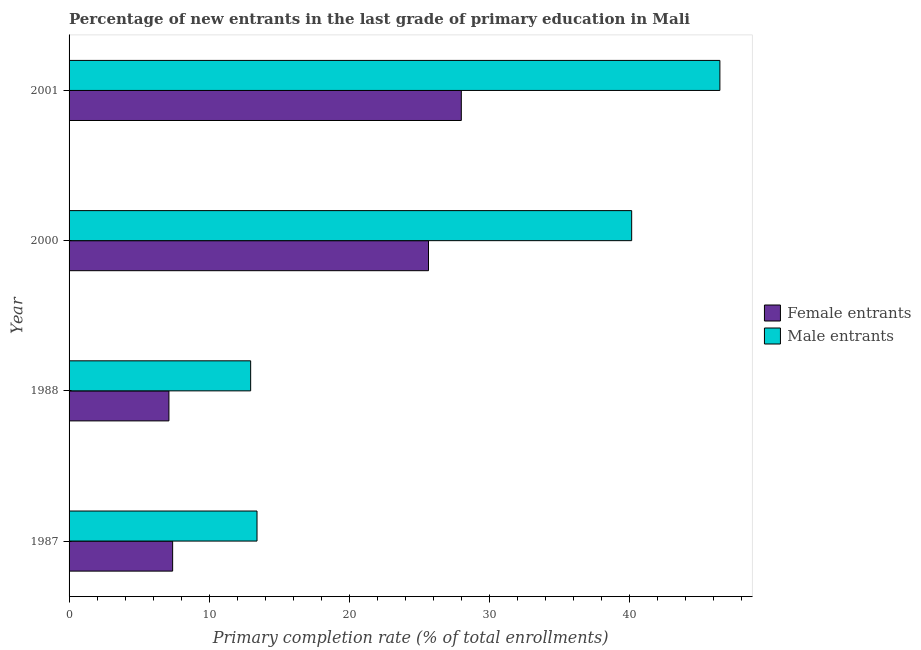How many different coloured bars are there?
Offer a very short reply. 2. How many groups of bars are there?
Your response must be concise. 4. How many bars are there on the 1st tick from the top?
Keep it short and to the point. 2. How many bars are there on the 1st tick from the bottom?
Your answer should be very brief. 2. In how many cases, is the number of bars for a given year not equal to the number of legend labels?
Give a very brief answer. 0. What is the primary completion rate of male entrants in 2000?
Ensure brevity in your answer.  40.15. Across all years, what is the maximum primary completion rate of male entrants?
Offer a terse response. 46.45. Across all years, what is the minimum primary completion rate of male entrants?
Offer a very short reply. 12.96. In which year was the primary completion rate of male entrants minimum?
Provide a short and direct response. 1988. What is the total primary completion rate of male entrants in the graph?
Ensure brevity in your answer.  112.97. What is the difference between the primary completion rate of female entrants in 2000 and that in 2001?
Provide a short and direct response. -2.34. What is the difference between the primary completion rate of female entrants in 2000 and the primary completion rate of male entrants in 1988?
Provide a succinct answer. 12.69. What is the average primary completion rate of female entrants per year?
Your answer should be compact. 17.04. In the year 2001, what is the difference between the primary completion rate of female entrants and primary completion rate of male entrants?
Provide a succinct answer. -18.45. In how many years, is the primary completion rate of male entrants greater than 46 %?
Provide a short and direct response. 1. What is the ratio of the primary completion rate of male entrants in 1987 to that in 2000?
Your answer should be very brief. 0.33. Is the primary completion rate of male entrants in 1987 less than that in 1988?
Your answer should be very brief. No. What is the difference between the highest and the second highest primary completion rate of male entrants?
Provide a succinct answer. 6.3. What is the difference between the highest and the lowest primary completion rate of female entrants?
Ensure brevity in your answer.  20.87. In how many years, is the primary completion rate of female entrants greater than the average primary completion rate of female entrants taken over all years?
Provide a succinct answer. 2. What does the 1st bar from the top in 2000 represents?
Provide a succinct answer. Male entrants. What does the 2nd bar from the bottom in 2001 represents?
Give a very brief answer. Male entrants. Are all the bars in the graph horizontal?
Make the answer very short. Yes. How many years are there in the graph?
Offer a terse response. 4. Are the values on the major ticks of X-axis written in scientific E-notation?
Offer a very short reply. No. Where does the legend appear in the graph?
Offer a terse response. Center right. How are the legend labels stacked?
Your answer should be compact. Vertical. What is the title of the graph?
Make the answer very short. Percentage of new entrants in the last grade of primary education in Mali. Does "Resident workers" appear as one of the legend labels in the graph?
Provide a succinct answer. No. What is the label or title of the X-axis?
Ensure brevity in your answer.  Primary completion rate (% of total enrollments). What is the label or title of the Y-axis?
Provide a succinct answer. Year. What is the Primary completion rate (% of total enrollments) in Female entrants in 1987?
Give a very brief answer. 7.39. What is the Primary completion rate (% of total enrollments) of Male entrants in 1987?
Provide a succinct answer. 13.41. What is the Primary completion rate (% of total enrollments) of Female entrants in 1988?
Provide a short and direct response. 7.13. What is the Primary completion rate (% of total enrollments) in Male entrants in 1988?
Offer a very short reply. 12.96. What is the Primary completion rate (% of total enrollments) in Female entrants in 2000?
Your response must be concise. 25.65. What is the Primary completion rate (% of total enrollments) of Male entrants in 2000?
Your answer should be very brief. 40.15. What is the Primary completion rate (% of total enrollments) of Female entrants in 2001?
Offer a very short reply. 27.99. What is the Primary completion rate (% of total enrollments) of Male entrants in 2001?
Your response must be concise. 46.45. Across all years, what is the maximum Primary completion rate (% of total enrollments) of Female entrants?
Your answer should be very brief. 27.99. Across all years, what is the maximum Primary completion rate (% of total enrollments) in Male entrants?
Keep it short and to the point. 46.45. Across all years, what is the minimum Primary completion rate (% of total enrollments) in Female entrants?
Keep it short and to the point. 7.13. Across all years, what is the minimum Primary completion rate (% of total enrollments) in Male entrants?
Offer a terse response. 12.96. What is the total Primary completion rate (% of total enrollments) in Female entrants in the graph?
Give a very brief answer. 68.16. What is the total Primary completion rate (% of total enrollments) of Male entrants in the graph?
Your response must be concise. 112.97. What is the difference between the Primary completion rate (% of total enrollments) of Female entrants in 1987 and that in 1988?
Keep it short and to the point. 0.27. What is the difference between the Primary completion rate (% of total enrollments) in Male entrants in 1987 and that in 1988?
Your answer should be very brief. 0.45. What is the difference between the Primary completion rate (% of total enrollments) in Female entrants in 1987 and that in 2000?
Your response must be concise. -18.26. What is the difference between the Primary completion rate (% of total enrollments) in Male entrants in 1987 and that in 2000?
Provide a short and direct response. -26.74. What is the difference between the Primary completion rate (% of total enrollments) of Female entrants in 1987 and that in 2001?
Give a very brief answer. -20.6. What is the difference between the Primary completion rate (% of total enrollments) of Male entrants in 1987 and that in 2001?
Provide a succinct answer. -33.03. What is the difference between the Primary completion rate (% of total enrollments) in Female entrants in 1988 and that in 2000?
Your answer should be compact. -18.52. What is the difference between the Primary completion rate (% of total enrollments) in Male entrants in 1988 and that in 2000?
Your answer should be compact. -27.19. What is the difference between the Primary completion rate (% of total enrollments) of Female entrants in 1988 and that in 2001?
Your answer should be compact. -20.87. What is the difference between the Primary completion rate (% of total enrollments) in Male entrants in 1988 and that in 2001?
Your answer should be very brief. -33.49. What is the difference between the Primary completion rate (% of total enrollments) of Female entrants in 2000 and that in 2001?
Give a very brief answer. -2.34. What is the difference between the Primary completion rate (% of total enrollments) of Male entrants in 2000 and that in 2001?
Give a very brief answer. -6.3. What is the difference between the Primary completion rate (% of total enrollments) of Female entrants in 1987 and the Primary completion rate (% of total enrollments) of Male entrants in 1988?
Provide a short and direct response. -5.57. What is the difference between the Primary completion rate (% of total enrollments) in Female entrants in 1987 and the Primary completion rate (% of total enrollments) in Male entrants in 2000?
Give a very brief answer. -32.76. What is the difference between the Primary completion rate (% of total enrollments) in Female entrants in 1987 and the Primary completion rate (% of total enrollments) in Male entrants in 2001?
Make the answer very short. -39.05. What is the difference between the Primary completion rate (% of total enrollments) of Female entrants in 1988 and the Primary completion rate (% of total enrollments) of Male entrants in 2000?
Keep it short and to the point. -33.02. What is the difference between the Primary completion rate (% of total enrollments) of Female entrants in 1988 and the Primary completion rate (% of total enrollments) of Male entrants in 2001?
Your response must be concise. -39.32. What is the difference between the Primary completion rate (% of total enrollments) of Female entrants in 2000 and the Primary completion rate (% of total enrollments) of Male entrants in 2001?
Give a very brief answer. -20.8. What is the average Primary completion rate (% of total enrollments) in Female entrants per year?
Provide a short and direct response. 17.04. What is the average Primary completion rate (% of total enrollments) of Male entrants per year?
Offer a terse response. 28.24. In the year 1987, what is the difference between the Primary completion rate (% of total enrollments) of Female entrants and Primary completion rate (% of total enrollments) of Male entrants?
Your response must be concise. -6.02. In the year 1988, what is the difference between the Primary completion rate (% of total enrollments) in Female entrants and Primary completion rate (% of total enrollments) in Male entrants?
Offer a very short reply. -5.83. In the year 2000, what is the difference between the Primary completion rate (% of total enrollments) of Female entrants and Primary completion rate (% of total enrollments) of Male entrants?
Your response must be concise. -14.5. In the year 2001, what is the difference between the Primary completion rate (% of total enrollments) of Female entrants and Primary completion rate (% of total enrollments) of Male entrants?
Make the answer very short. -18.45. What is the ratio of the Primary completion rate (% of total enrollments) of Female entrants in 1987 to that in 1988?
Provide a short and direct response. 1.04. What is the ratio of the Primary completion rate (% of total enrollments) in Male entrants in 1987 to that in 1988?
Keep it short and to the point. 1.03. What is the ratio of the Primary completion rate (% of total enrollments) of Female entrants in 1987 to that in 2000?
Provide a succinct answer. 0.29. What is the ratio of the Primary completion rate (% of total enrollments) of Male entrants in 1987 to that in 2000?
Offer a very short reply. 0.33. What is the ratio of the Primary completion rate (% of total enrollments) of Female entrants in 1987 to that in 2001?
Offer a terse response. 0.26. What is the ratio of the Primary completion rate (% of total enrollments) of Male entrants in 1987 to that in 2001?
Your answer should be compact. 0.29. What is the ratio of the Primary completion rate (% of total enrollments) of Female entrants in 1988 to that in 2000?
Your response must be concise. 0.28. What is the ratio of the Primary completion rate (% of total enrollments) in Male entrants in 1988 to that in 2000?
Keep it short and to the point. 0.32. What is the ratio of the Primary completion rate (% of total enrollments) of Female entrants in 1988 to that in 2001?
Provide a succinct answer. 0.25. What is the ratio of the Primary completion rate (% of total enrollments) in Male entrants in 1988 to that in 2001?
Your answer should be compact. 0.28. What is the ratio of the Primary completion rate (% of total enrollments) of Female entrants in 2000 to that in 2001?
Offer a very short reply. 0.92. What is the ratio of the Primary completion rate (% of total enrollments) in Male entrants in 2000 to that in 2001?
Provide a short and direct response. 0.86. What is the difference between the highest and the second highest Primary completion rate (% of total enrollments) in Female entrants?
Provide a short and direct response. 2.34. What is the difference between the highest and the second highest Primary completion rate (% of total enrollments) in Male entrants?
Provide a succinct answer. 6.3. What is the difference between the highest and the lowest Primary completion rate (% of total enrollments) in Female entrants?
Your answer should be compact. 20.87. What is the difference between the highest and the lowest Primary completion rate (% of total enrollments) in Male entrants?
Provide a short and direct response. 33.49. 